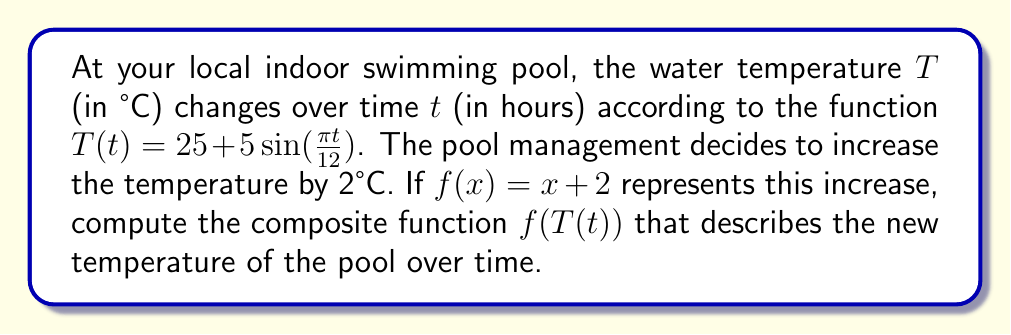Can you solve this math problem? To find the composite function $f(T(t))$, we need to apply the following steps:

1. Identify the inner function: $T(t) = 25 + 5\sin(\frac{\pi t}{12})$
2. Identify the outer function: $f(x) = x + 2$
3. Replace $x$ in the outer function with the entire inner function:

   $f(T(t)) = T(t) + 2$

4. Substitute the expression for $T(t)$ into this equation:

   $f(T(t)) = (25 + 5\sin(\frac{\pi t}{12})) + 2$

5. Simplify:

   $f(T(t)) = 25 + 5\sin(\frac{\pi t}{12}) + 2$
   $f(T(t)) = 27 + 5\sin(\frac{\pi t}{12})$

This resulting function represents the new temperature of the pool over time, which is 2°C higher than the original temperature at all times.
Answer: $f(T(t)) = 27 + 5\sin(\frac{\pi t}{12})$ 